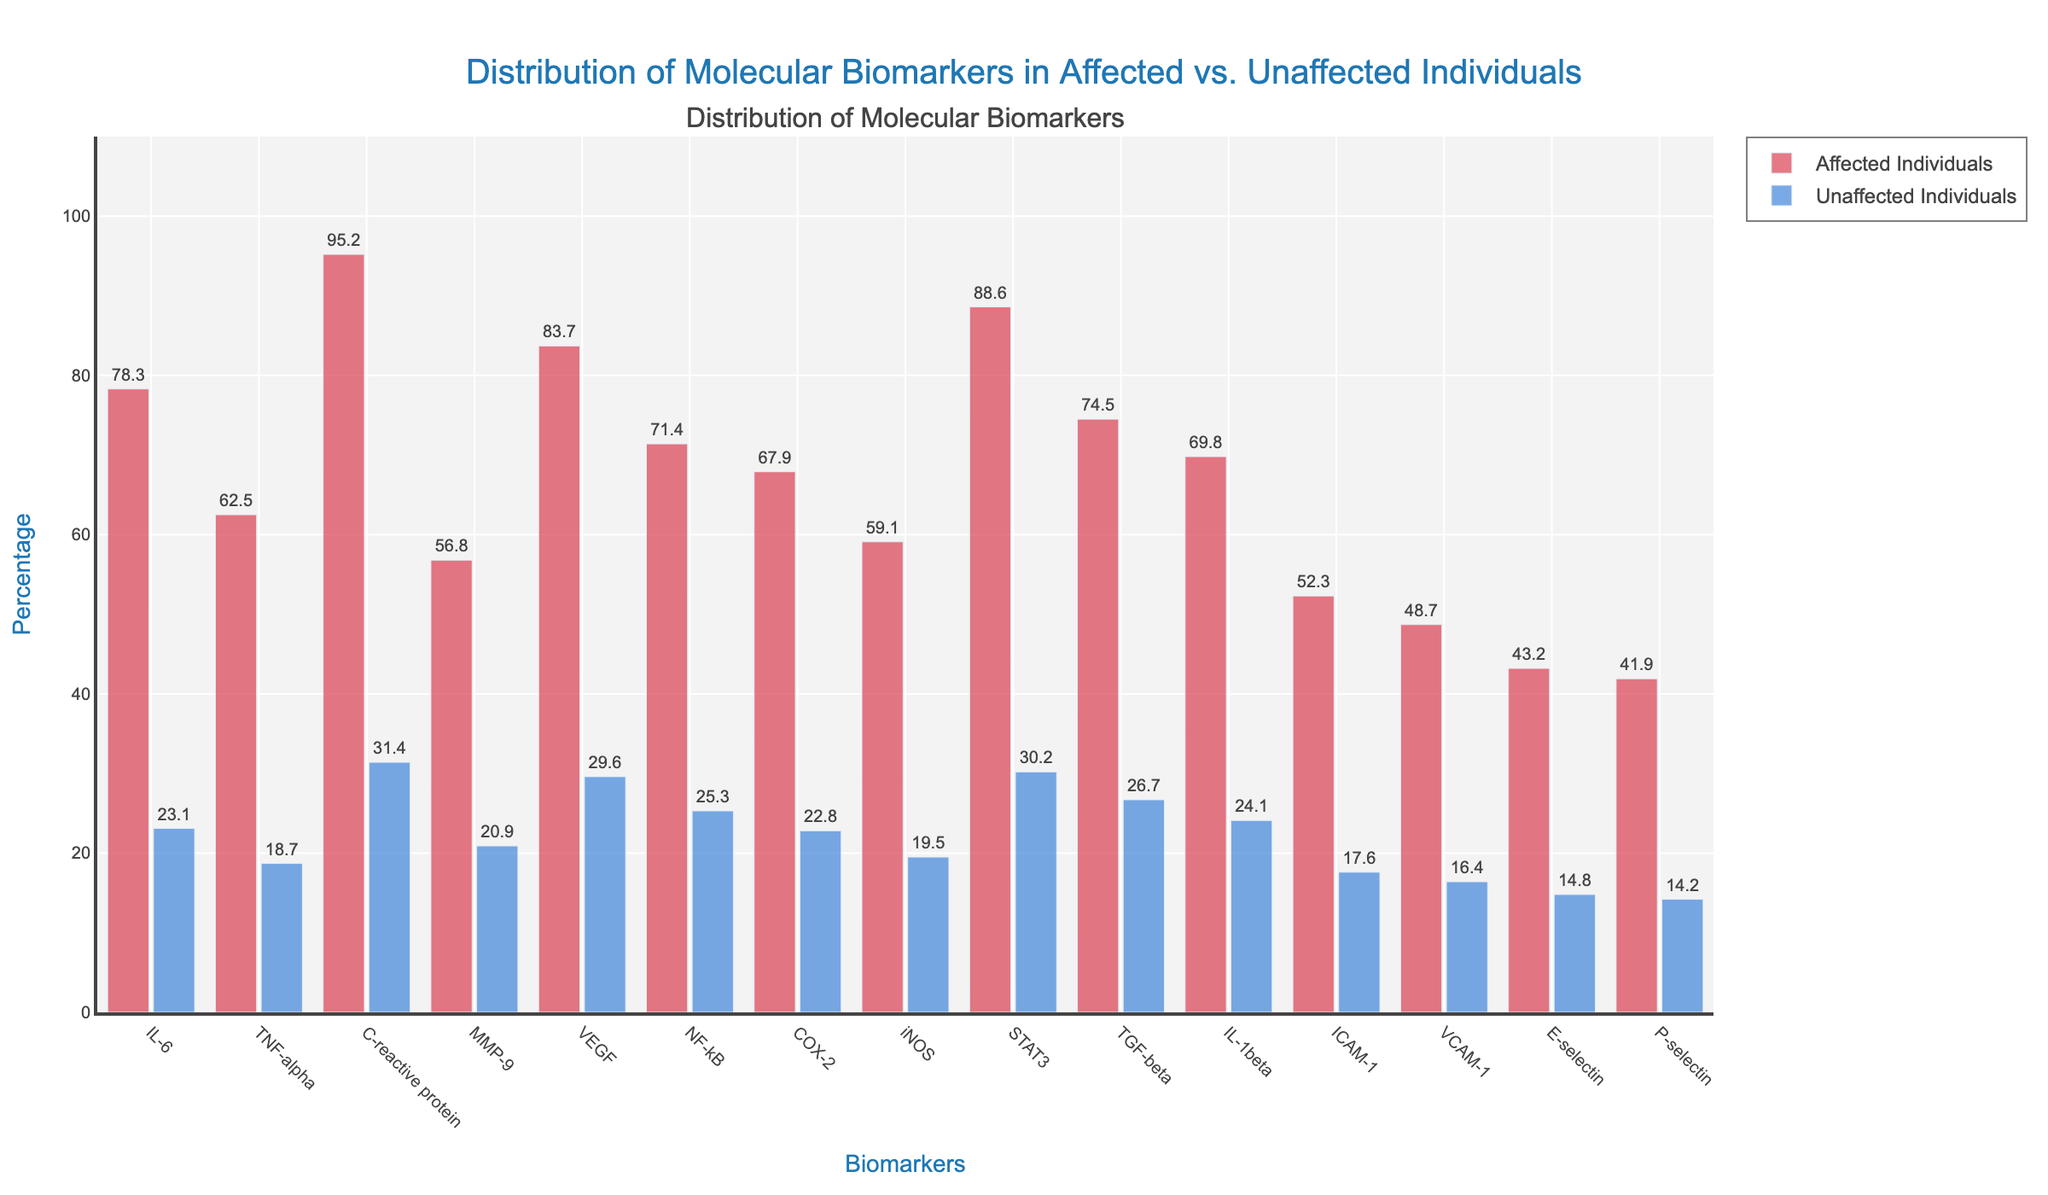What's the difference in IL-6 levels between affected and unaffected individuals? To find the difference in IL-6 levels between the two groups, subtract the Unaffected_Individuals value from the Affected_Individuals value. Thus, 78.3 - 23.1 = 55.2.
Answer: 55.2 Which biomarker has the largest difference in levels between affected and unaffected individuals? To determine this, calculate the differences for all biomarkers and identify the largest one. **IL-6** has a difference of 55.2, **TNF-alpha** has 43.8, **C-reactive protein** has 63.8 (the largest), **MMP-9** has 35.9, **VEGF** has 54.1, **NF-kB** has 46.1, **COX-2** has 45.1, **iNOS** has 39.6, **STAT3** has 58.4, **TGF-beta** has 47.8, **IL-1beta** has 45.7, **ICAM-1** has 34.7, **VCAM-1** has 32.3, **E-selectin** has 28.4, **P-selectin** has 27.7. Thus, **C-reactive protein** has the largest difference.
Answer: C-reactive protein Which group has higher levels of biomarkers overall, affected or unaffected individuals? By visually inspecting the bar heights across all biomarkers, it can be seen that the bars representing Affected Individuals (colored in red) are consistently higher than those representing Unaffected Individuals (colored in blue). Therefore, overall, the affected individuals have higher biomarker levels.
Answer: Affected Individuals What is the average level of C-reactive protein for affected and unaffected individuals? To find the average of C-reactive protein levels for both groups, add the values for affected and unaffected individuals and then divide by 2. Thus, (95.2 + 31.4) / 2 = 63.3.
Answer: 63.3 Which biomarker has the smallest level difference between affected and unaffected individuals? To find the smallest difference, calculate the difference for each biomarker: **IL-6** (55.2), **TNF-alpha** (43.8), **C-reactive protein** (63.8), **MMP-9** (35.9), **VEGF** (54.1), **NF-kB** (46.1), **COX-2** (45.1), **iNOS** (39.6), **STAT3** (58.4), **TGF-beta** (47.8), **IL-1beta** (45.7), **ICAM-1** (34.7), **VCAM-1** (32.3), **E-selectin** (28.4), **P-selectin** (27.7). The smallest difference is for **P-selectin**.
Answer: P-selectin Is the level of VEGF in affected individuals greater than 80%? By inspecting the height of the bar for VEGF in affected individuals, we see it reaches 83.7, which is greater than 80%.
Answer: Yes How does the level of TNF-alpha in affected individuals compare to the level of VEGF in unaffected individuals? From the bar heights, the level of TNF-alpha in affected individuals is 62.5, while the level of VEGF in unaffected individuals is 29.6. TNF-alpha in affected individuals is higher.
Answer: Higher What is the range of molecular biomarker levels in unaffected individuals? The range is determined by subtracting the smallest value from the largest value among unaffected individuals. The smallest value is for P-selectin (14.2) and the largest value is for C-reactive protein (31.4). Hence, the range is 31.4 - 14.2 = 17.2.
Answer: 17.2 How many biomarkers in affected individuals have levels above 70? By visually inspecting the bar heights for affected individuals, the biomarkers with levels above 70 are **IL-6** (78.3), **VEGF** (83.7), **NF-kB** (71.4), **C-reactive protein** (95.2), **STAT3** (88.6), **TGF-beta** (74.5). Counting these gives 6.
Answer: 6 